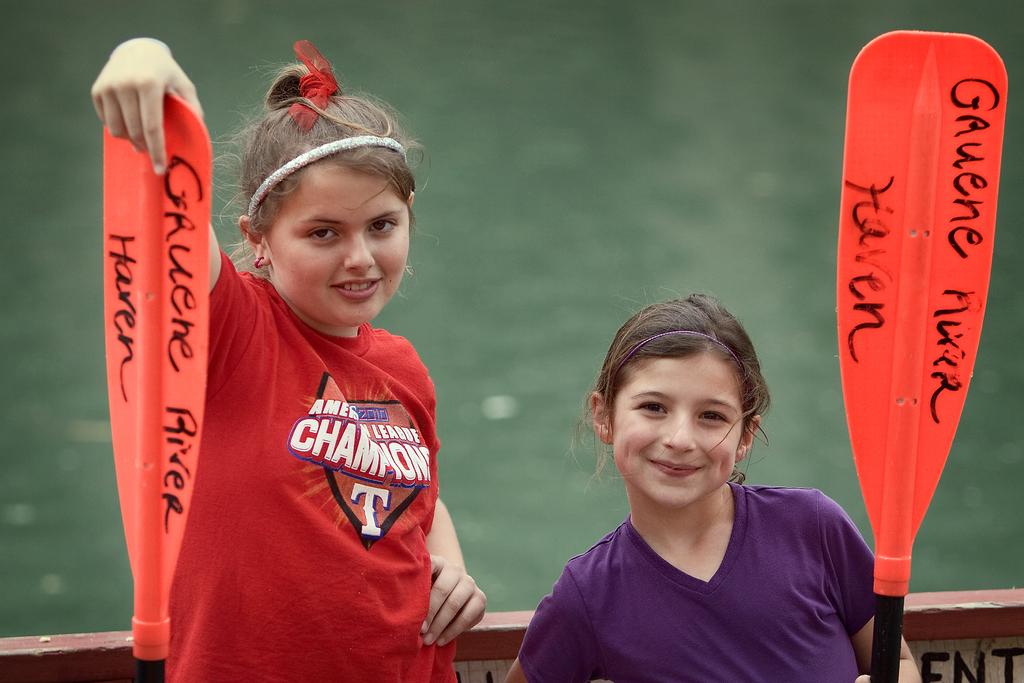Are both the girls the same heights ?
Keep it short and to the point. Answering does not require reading text in the image. What does the paddle on the right say?
Offer a very short reply. Unanswerable. 